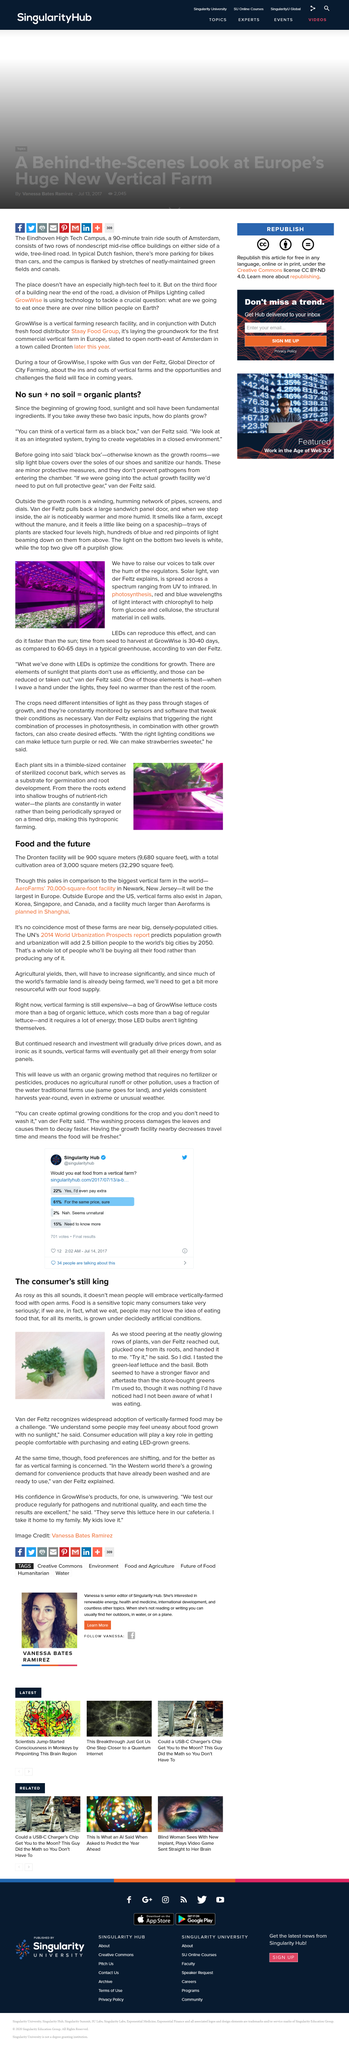Highlight a few significant elements in this photo. In photosynthesis, red and blue wavelengths of light interact with chlorophyll to help form glucose and cellulose. The time from seed to harvest in a typical greenhouse typically takes 60-65 days. The cultivation area of the Dronten facility will be 3,000 square meters, equivalent to 32,290 square feet. The Dronten facility will engage in hydroponic farming, which is a type of agriculture that utilizes a nutrient-rich solution to support plant growth, rather than soil. At GrowWise, it typically takes 30-40 days from seed to harvest. 